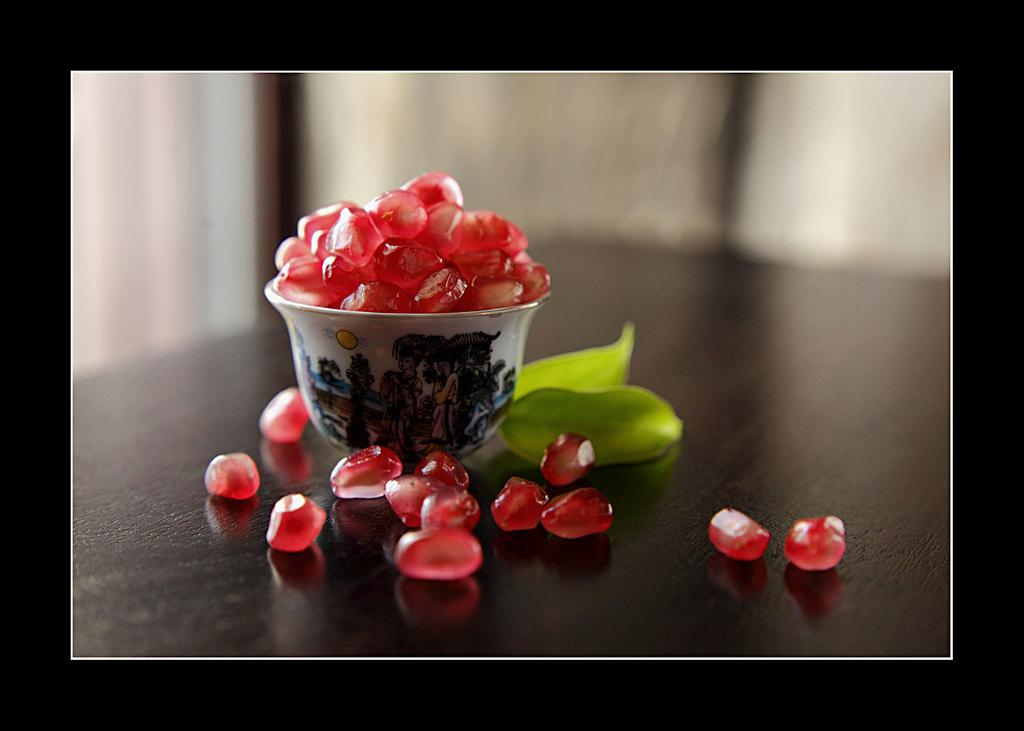What is on the table in the image? There is a bowl on the table, and it contains pomegranate seeds. Are there any pomegranate seeds outside of the bowl? Yes, there are pomegranate seeds on the table. What else can be seen on the table? There is a leaf visible on the table. How would you describe the background of the image? The background of the image is blurred. What theory is being proposed by the pomegranate seeds in the image? There is no theory being proposed by the pomegranate seeds in the image; they are simply a type of fruit. Can you see any twigs on the table in the image? There is no mention of twigs in the image; only a bowl, pomegranate seeds, a leaf, and a blurred background are described. 